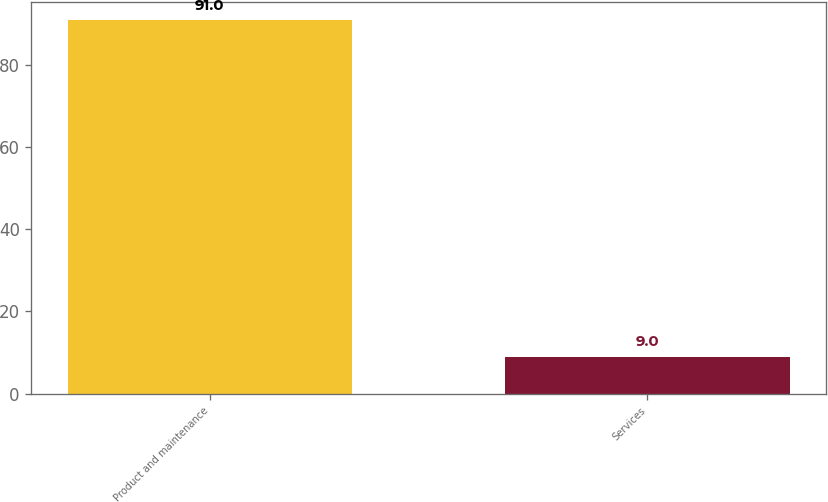<chart> <loc_0><loc_0><loc_500><loc_500><bar_chart><fcel>Product and maintenance<fcel>Services<nl><fcel>91<fcel>9<nl></chart> 